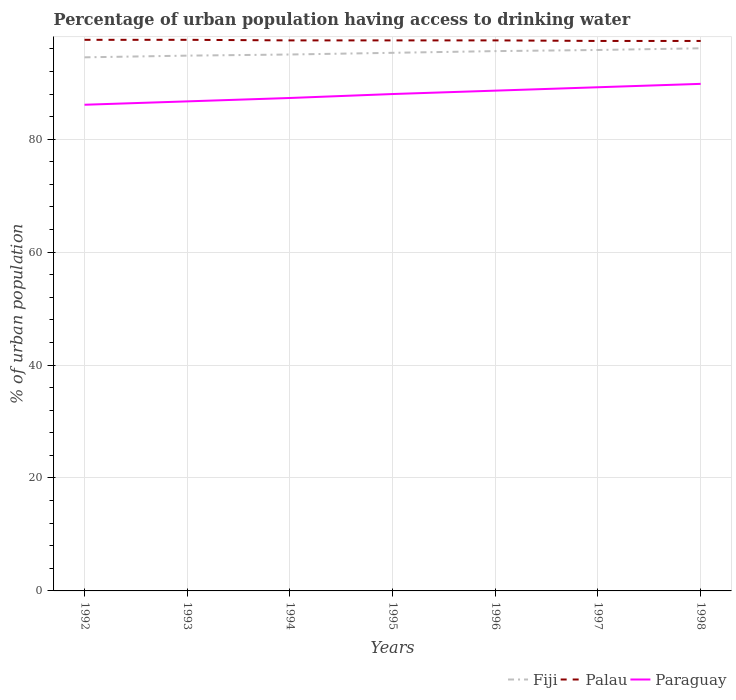How many different coloured lines are there?
Your answer should be compact. 3. Across all years, what is the maximum percentage of urban population having access to drinking water in Palau?
Offer a very short reply. 97.4. What is the difference between the highest and the second highest percentage of urban population having access to drinking water in Paraguay?
Provide a short and direct response. 3.7. What is the difference between the highest and the lowest percentage of urban population having access to drinking water in Fiji?
Provide a short and direct response. 3. How many years are there in the graph?
Provide a succinct answer. 7. Are the values on the major ticks of Y-axis written in scientific E-notation?
Provide a succinct answer. No. Does the graph contain grids?
Make the answer very short. Yes. Where does the legend appear in the graph?
Your answer should be very brief. Bottom right. How are the legend labels stacked?
Make the answer very short. Horizontal. What is the title of the graph?
Give a very brief answer. Percentage of urban population having access to drinking water. Does "Turkey" appear as one of the legend labels in the graph?
Offer a terse response. No. What is the label or title of the X-axis?
Ensure brevity in your answer.  Years. What is the label or title of the Y-axis?
Ensure brevity in your answer.  % of urban population. What is the % of urban population of Fiji in 1992?
Make the answer very short. 94.5. What is the % of urban population of Palau in 1992?
Provide a short and direct response. 97.6. What is the % of urban population in Paraguay in 1992?
Your response must be concise. 86.1. What is the % of urban population of Fiji in 1993?
Your answer should be compact. 94.8. What is the % of urban population in Palau in 1993?
Make the answer very short. 97.6. What is the % of urban population of Paraguay in 1993?
Your answer should be compact. 86.7. What is the % of urban population in Palau in 1994?
Provide a short and direct response. 97.5. What is the % of urban population in Paraguay in 1994?
Your response must be concise. 87.3. What is the % of urban population of Fiji in 1995?
Provide a succinct answer. 95.3. What is the % of urban population of Palau in 1995?
Make the answer very short. 97.5. What is the % of urban population of Fiji in 1996?
Provide a succinct answer. 95.6. What is the % of urban population of Palau in 1996?
Provide a succinct answer. 97.5. What is the % of urban population of Paraguay in 1996?
Give a very brief answer. 88.6. What is the % of urban population in Fiji in 1997?
Ensure brevity in your answer.  95.8. What is the % of urban population of Palau in 1997?
Keep it short and to the point. 97.4. What is the % of urban population of Paraguay in 1997?
Give a very brief answer. 89.2. What is the % of urban population in Fiji in 1998?
Your answer should be compact. 96.1. What is the % of urban population in Palau in 1998?
Provide a succinct answer. 97.4. What is the % of urban population of Paraguay in 1998?
Provide a short and direct response. 89.8. Across all years, what is the maximum % of urban population of Fiji?
Ensure brevity in your answer.  96.1. Across all years, what is the maximum % of urban population in Palau?
Ensure brevity in your answer.  97.6. Across all years, what is the maximum % of urban population of Paraguay?
Your answer should be very brief. 89.8. Across all years, what is the minimum % of urban population of Fiji?
Make the answer very short. 94.5. Across all years, what is the minimum % of urban population in Palau?
Offer a terse response. 97.4. Across all years, what is the minimum % of urban population of Paraguay?
Your answer should be compact. 86.1. What is the total % of urban population in Fiji in the graph?
Offer a very short reply. 667.1. What is the total % of urban population of Palau in the graph?
Provide a succinct answer. 682.5. What is the total % of urban population in Paraguay in the graph?
Your response must be concise. 615.7. What is the difference between the % of urban population in Fiji in 1992 and that in 1993?
Provide a succinct answer. -0.3. What is the difference between the % of urban population in Palau in 1992 and that in 1993?
Ensure brevity in your answer.  0. What is the difference between the % of urban population in Paraguay in 1992 and that in 1994?
Ensure brevity in your answer.  -1.2. What is the difference between the % of urban population in Fiji in 1992 and that in 1995?
Make the answer very short. -0.8. What is the difference between the % of urban population in Palau in 1992 and that in 1995?
Provide a short and direct response. 0.1. What is the difference between the % of urban population in Paraguay in 1992 and that in 1995?
Your response must be concise. -1.9. What is the difference between the % of urban population of Fiji in 1992 and that in 1996?
Your response must be concise. -1.1. What is the difference between the % of urban population of Paraguay in 1992 and that in 1996?
Provide a succinct answer. -2.5. What is the difference between the % of urban population in Palau in 1992 and that in 1998?
Your answer should be very brief. 0.2. What is the difference between the % of urban population of Fiji in 1993 and that in 1994?
Your answer should be very brief. -0.2. What is the difference between the % of urban population of Palau in 1993 and that in 1994?
Make the answer very short. 0.1. What is the difference between the % of urban population of Paraguay in 1993 and that in 1994?
Ensure brevity in your answer.  -0.6. What is the difference between the % of urban population in Fiji in 1993 and that in 1995?
Give a very brief answer. -0.5. What is the difference between the % of urban population of Palau in 1993 and that in 1995?
Your answer should be very brief. 0.1. What is the difference between the % of urban population of Fiji in 1993 and that in 1996?
Your answer should be compact. -0.8. What is the difference between the % of urban population of Palau in 1993 and that in 1996?
Make the answer very short. 0.1. What is the difference between the % of urban population in Palau in 1993 and that in 1997?
Provide a succinct answer. 0.2. What is the difference between the % of urban population in Fiji in 1993 and that in 1998?
Your answer should be very brief. -1.3. What is the difference between the % of urban population in Palau in 1993 and that in 1998?
Provide a short and direct response. 0.2. What is the difference between the % of urban population in Fiji in 1994 and that in 1995?
Make the answer very short. -0.3. What is the difference between the % of urban population in Paraguay in 1994 and that in 1995?
Your answer should be very brief. -0.7. What is the difference between the % of urban population of Fiji in 1994 and that in 1996?
Your response must be concise. -0.6. What is the difference between the % of urban population in Palau in 1994 and that in 1996?
Offer a very short reply. 0. What is the difference between the % of urban population in Palau in 1994 and that in 1997?
Keep it short and to the point. 0.1. What is the difference between the % of urban population of Paraguay in 1994 and that in 1997?
Ensure brevity in your answer.  -1.9. What is the difference between the % of urban population in Palau in 1994 and that in 1998?
Your answer should be compact. 0.1. What is the difference between the % of urban population of Paraguay in 1994 and that in 1998?
Make the answer very short. -2.5. What is the difference between the % of urban population in Palau in 1995 and that in 1996?
Keep it short and to the point. 0. What is the difference between the % of urban population in Fiji in 1995 and that in 1997?
Keep it short and to the point. -0.5. What is the difference between the % of urban population of Paraguay in 1995 and that in 1997?
Provide a short and direct response. -1.2. What is the difference between the % of urban population in Palau in 1995 and that in 1998?
Give a very brief answer. 0.1. What is the difference between the % of urban population of Fiji in 1996 and that in 1997?
Your answer should be compact. -0.2. What is the difference between the % of urban population in Palau in 1996 and that in 1997?
Make the answer very short. 0.1. What is the difference between the % of urban population in Fiji in 1996 and that in 1998?
Your response must be concise. -0.5. What is the difference between the % of urban population of Fiji in 1992 and the % of urban population of Palau in 1994?
Your answer should be very brief. -3. What is the difference between the % of urban population of Fiji in 1992 and the % of urban population of Paraguay in 1994?
Offer a terse response. 7.2. What is the difference between the % of urban population in Palau in 1992 and the % of urban population in Paraguay in 1994?
Provide a short and direct response. 10.3. What is the difference between the % of urban population of Palau in 1992 and the % of urban population of Paraguay in 1995?
Keep it short and to the point. 9.6. What is the difference between the % of urban population in Fiji in 1992 and the % of urban population in Paraguay in 1997?
Make the answer very short. 5.3. What is the difference between the % of urban population in Fiji in 1992 and the % of urban population in Palau in 1998?
Provide a succinct answer. -2.9. What is the difference between the % of urban population of Palau in 1992 and the % of urban population of Paraguay in 1998?
Make the answer very short. 7.8. What is the difference between the % of urban population in Fiji in 1993 and the % of urban population in Paraguay in 1994?
Provide a succinct answer. 7.5. What is the difference between the % of urban population in Fiji in 1993 and the % of urban population in Paraguay in 1995?
Your answer should be compact. 6.8. What is the difference between the % of urban population of Palau in 1993 and the % of urban population of Paraguay in 1995?
Your answer should be compact. 9.6. What is the difference between the % of urban population of Fiji in 1993 and the % of urban population of Palau in 1996?
Your response must be concise. -2.7. What is the difference between the % of urban population in Fiji in 1993 and the % of urban population in Paraguay in 1997?
Offer a terse response. 5.6. What is the difference between the % of urban population of Palau in 1993 and the % of urban population of Paraguay in 1997?
Give a very brief answer. 8.4. What is the difference between the % of urban population of Fiji in 1994 and the % of urban population of Palau in 1995?
Give a very brief answer. -2.5. What is the difference between the % of urban population in Fiji in 1994 and the % of urban population in Palau in 1996?
Offer a very short reply. -2.5. What is the difference between the % of urban population of Fiji in 1994 and the % of urban population of Paraguay in 1996?
Your answer should be very brief. 6.4. What is the difference between the % of urban population in Palau in 1994 and the % of urban population in Paraguay in 1996?
Ensure brevity in your answer.  8.9. What is the difference between the % of urban population in Fiji in 1994 and the % of urban population in Palau in 1997?
Your response must be concise. -2.4. What is the difference between the % of urban population of Palau in 1994 and the % of urban population of Paraguay in 1997?
Provide a succinct answer. 8.3. What is the difference between the % of urban population of Fiji in 1995 and the % of urban population of Palau in 1996?
Your answer should be very brief. -2.2. What is the difference between the % of urban population of Palau in 1995 and the % of urban population of Paraguay in 1996?
Ensure brevity in your answer.  8.9. What is the difference between the % of urban population of Fiji in 1995 and the % of urban population of Paraguay in 1997?
Your answer should be compact. 6.1. What is the difference between the % of urban population of Palau in 1995 and the % of urban population of Paraguay in 1997?
Keep it short and to the point. 8.3. What is the difference between the % of urban population in Fiji in 1995 and the % of urban population in Palau in 1998?
Offer a very short reply. -2.1. What is the difference between the % of urban population of Fiji in 1995 and the % of urban population of Paraguay in 1998?
Offer a very short reply. 5.5. What is the difference between the % of urban population in Fiji in 1996 and the % of urban population in Paraguay in 1997?
Provide a short and direct response. 6.4. What is the difference between the % of urban population in Fiji in 1996 and the % of urban population in Paraguay in 1998?
Give a very brief answer. 5.8. What is the difference between the % of urban population of Palau in 1996 and the % of urban population of Paraguay in 1998?
Give a very brief answer. 7.7. What is the difference between the % of urban population in Fiji in 1997 and the % of urban population in Paraguay in 1998?
Make the answer very short. 6. What is the difference between the % of urban population of Palau in 1997 and the % of urban population of Paraguay in 1998?
Ensure brevity in your answer.  7.6. What is the average % of urban population of Fiji per year?
Your answer should be compact. 95.3. What is the average % of urban population of Palau per year?
Your response must be concise. 97.5. What is the average % of urban population of Paraguay per year?
Ensure brevity in your answer.  87.96. In the year 1992, what is the difference between the % of urban population of Fiji and % of urban population of Palau?
Ensure brevity in your answer.  -3.1. In the year 1992, what is the difference between the % of urban population of Fiji and % of urban population of Paraguay?
Your response must be concise. 8.4. In the year 1992, what is the difference between the % of urban population in Palau and % of urban population in Paraguay?
Make the answer very short. 11.5. In the year 1994, what is the difference between the % of urban population in Fiji and % of urban population in Paraguay?
Provide a succinct answer. 7.7. In the year 1994, what is the difference between the % of urban population in Palau and % of urban population in Paraguay?
Make the answer very short. 10.2. In the year 1995, what is the difference between the % of urban population of Fiji and % of urban population of Paraguay?
Give a very brief answer. 7.3. In the year 1995, what is the difference between the % of urban population of Palau and % of urban population of Paraguay?
Offer a very short reply. 9.5. In the year 1996, what is the difference between the % of urban population of Fiji and % of urban population of Paraguay?
Give a very brief answer. 7. In the year 1997, what is the difference between the % of urban population of Fiji and % of urban population of Paraguay?
Make the answer very short. 6.6. In the year 1997, what is the difference between the % of urban population of Palau and % of urban population of Paraguay?
Your answer should be compact. 8.2. In the year 1998, what is the difference between the % of urban population in Fiji and % of urban population in Palau?
Give a very brief answer. -1.3. In the year 1998, what is the difference between the % of urban population in Fiji and % of urban population in Paraguay?
Keep it short and to the point. 6.3. What is the ratio of the % of urban population of Palau in 1992 to that in 1994?
Offer a terse response. 1. What is the ratio of the % of urban population of Paraguay in 1992 to that in 1994?
Make the answer very short. 0.99. What is the ratio of the % of urban population of Palau in 1992 to that in 1995?
Your response must be concise. 1. What is the ratio of the % of urban population in Paraguay in 1992 to that in 1995?
Ensure brevity in your answer.  0.98. What is the ratio of the % of urban population of Fiji in 1992 to that in 1996?
Ensure brevity in your answer.  0.99. What is the ratio of the % of urban population of Palau in 1992 to that in 1996?
Provide a succinct answer. 1. What is the ratio of the % of urban population in Paraguay in 1992 to that in 1996?
Make the answer very short. 0.97. What is the ratio of the % of urban population in Fiji in 1992 to that in 1997?
Keep it short and to the point. 0.99. What is the ratio of the % of urban population in Paraguay in 1992 to that in 1997?
Provide a short and direct response. 0.97. What is the ratio of the % of urban population of Fiji in 1992 to that in 1998?
Give a very brief answer. 0.98. What is the ratio of the % of urban population in Paraguay in 1992 to that in 1998?
Offer a terse response. 0.96. What is the ratio of the % of urban population of Fiji in 1993 to that in 1995?
Offer a terse response. 0.99. What is the ratio of the % of urban population in Paraguay in 1993 to that in 1995?
Give a very brief answer. 0.99. What is the ratio of the % of urban population of Paraguay in 1993 to that in 1996?
Keep it short and to the point. 0.98. What is the ratio of the % of urban population in Palau in 1993 to that in 1997?
Your answer should be very brief. 1. What is the ratio of the % of urban population in Paraguay in 1993 to that in 1997?
Offer a very short reply. 0.97. What is the ratio of the % of urban population of Fiji in 1993 to that in 1998?
Provide a succinct answer. 0.99. What is the ratio of the % of urban population in Paraguay in 1993 to that in 1998?
Your answer should be very brief. 0.97. What is the ratio of the % of urban population in Fiji in 1994 to that in 1995?
Make the answer very short. 1. What is the ratio of the % of urban population of Palau in 1994 to that in 1996?
Your response must be concise. 1. What is the ratio of the % of urban population in Paraguay in 1994 to that in 1996?
Your response must be concise. 0.99. What is the ratio of the % of urban population in Fiji in 1994 to that in 1997?
Offer a terse response. 0.99. What is the ratio of the % of urban population of Palau in 1994 to that in 1997?
Keep it short and to the point. 1. What is the ratio of the % of urban population in Paraguay in 1994 to that in 1997?
Your response must be concise. 0.98. What is the ratio of the % of urban population of Palau in 1994 to that in 1998?
Your answer should be very brief. 1. What is the ratio of the % of urban population of Paraguay in 1994 to that in 1998?
Give a very brief answer. 0.97. What is the ratio of the % of urban population in Fiji in 1995 to that in 1996?
Make the answer very short. 1. What is the ratio of the % of urban population of Palau in 1995 to that in 1996?
Make the answer very short. 1. What is the ratio of the % of urban population in Paraguay in 1995 to that in 1996?
Your response must be concise. 0.99. What is the ratio of the % of urban population in Fiji in 1995 to that in 1997?
Your answer should be very brief. 0.99. What is the ratio of the % of urban population in Paraguay in 1995 to that in 1997?
Provide a short and direct response. 0.99. What is the ratio of the % of urban population of Paraguay in 1995 to that in 1998?
Ensure brevity in your answer.  0.98. What is the ratio of the % of urban population in Fiji in 1996 to that in 1997?
Provide a short and direct response. 1. What is the ratio of the % of urban population of Palau in 1996 to that in 1997?
Your answer should be compact. 1. What is the ratio of the % of urban population of Paraguay in 1996 to that in 1997?
Your answer should be compact. 0.99. What is the ratio of the % of urban population of Fiji in 1996 to that in 1998?
Your response must be concise. 0.99. What is the ratio of the % of urban population of Paraguay in 1996 to that in 1998?
Provide a succinct answer. 0.99. What is the ratio of the % of urban population in Palau in 1997 to that in 1998?
Make the answer very short. 1. What is the ratio of the % of urban population in Paraguay in 1997 to that in 1998?
Ensure brevity in your answer.  0.99. What is the difference between the highest and the second highest % of urban population in Fiji?
Keep it short and to the point. 0.3. What is the difference between the highest and the second highest % of urban population of Palau?
Your answer should be compact. 0. What is the difference between the highest and the second highest % of urban population in Paraguay?
Provide a short and direct response. 0.6. What is the difference between the highest and the lowest % of urban population of Fiji?
Provide a succinct answer. 1.6. What is the difference between the highest and the lowest % of urban population of Palau?
Ensure brevity in your answer.  0.2. 